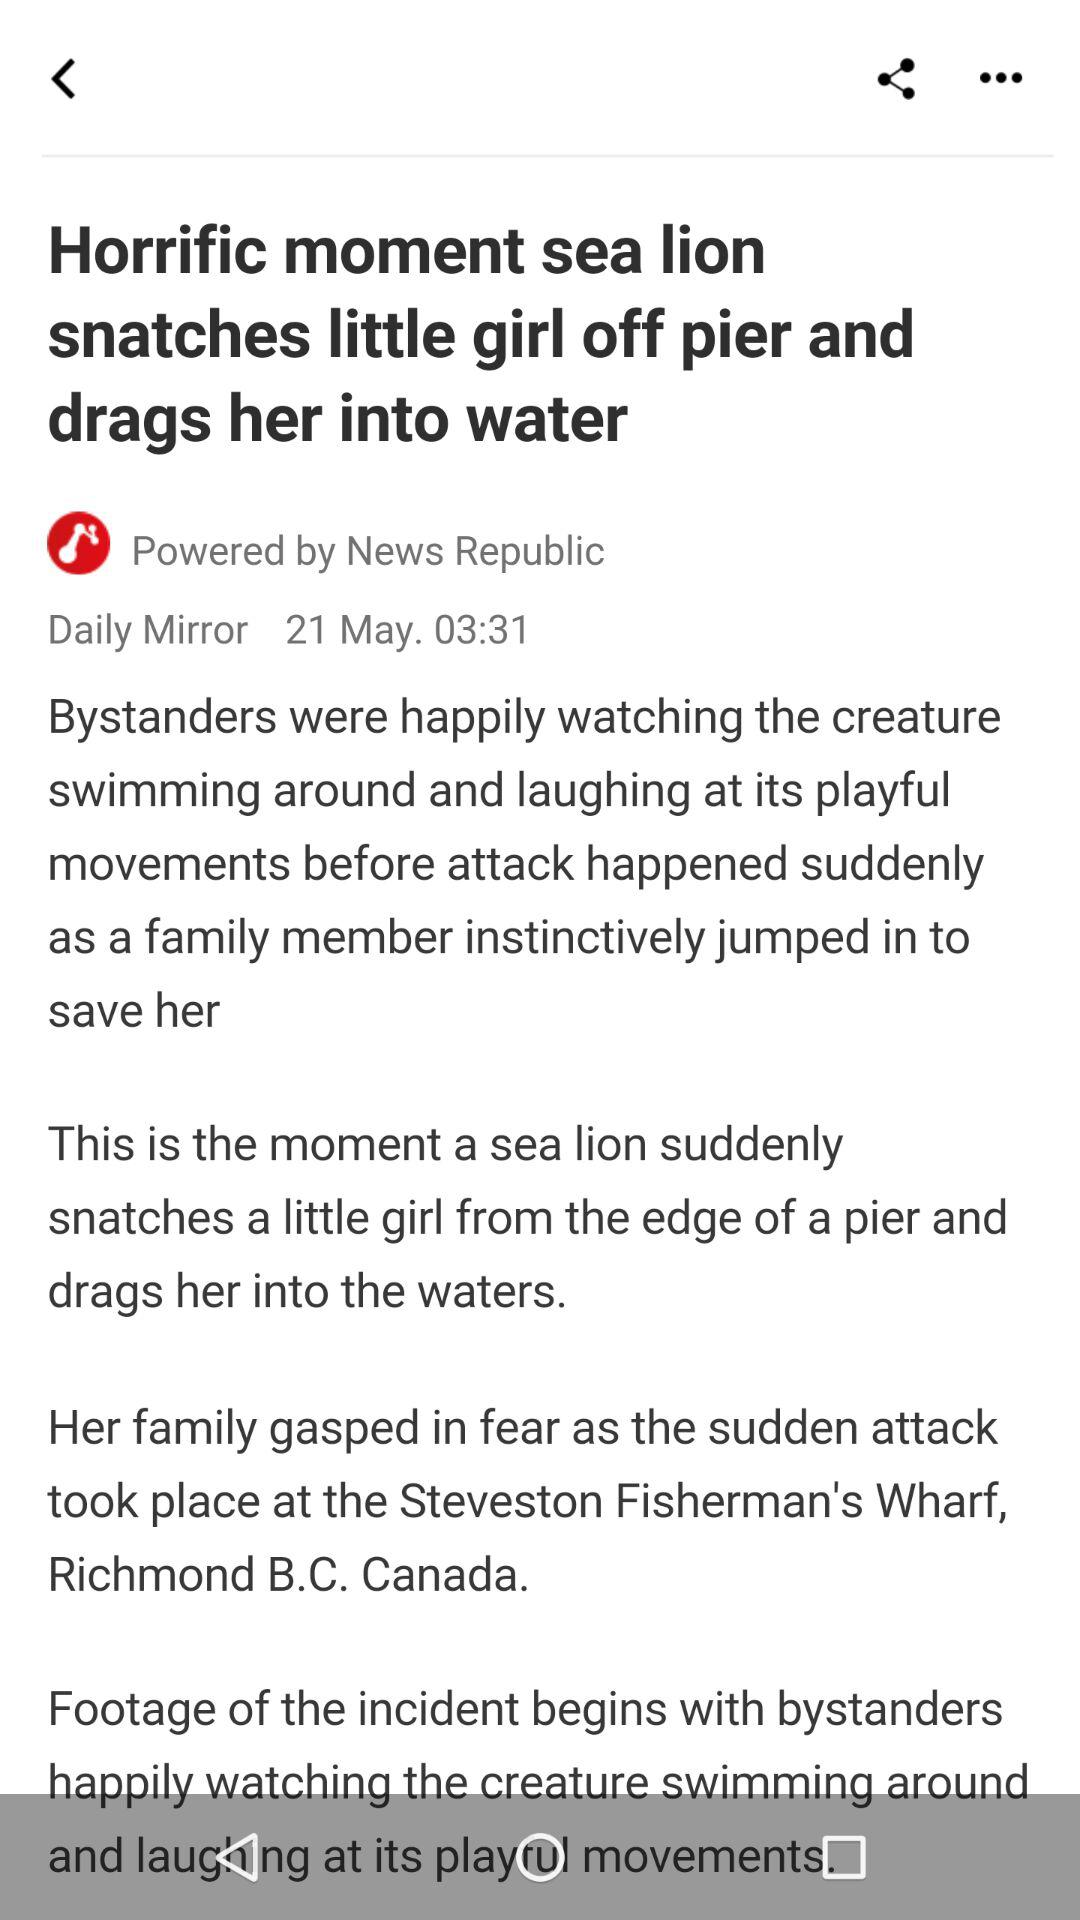What is the headline of the news? The headline of the news is "Horrific moment sea lion snatches little girl off pier and drags her into water". 